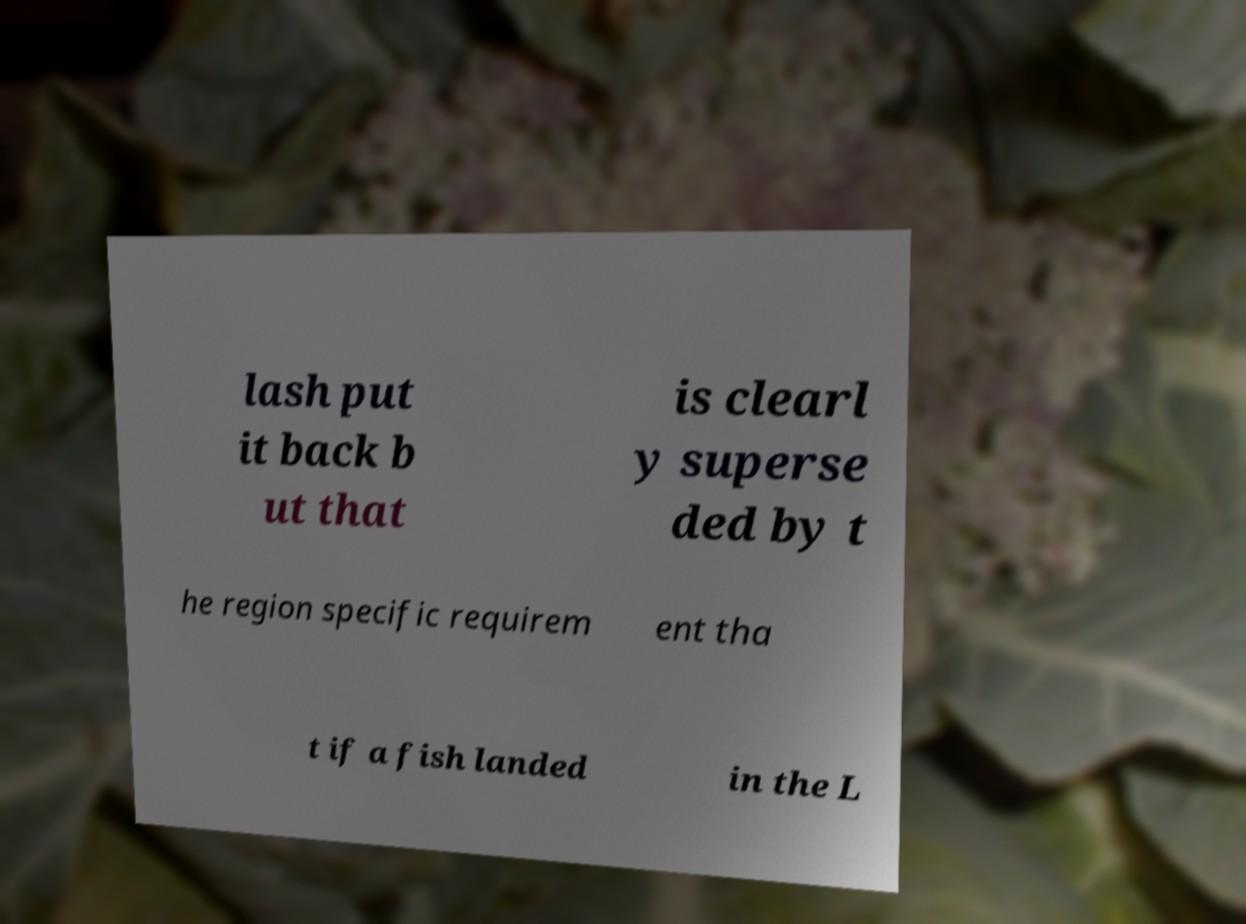What messages or text are displayed in this image? I need them in a readable, typed format. lash put it back b ut that is clearl y superse ded by t he region specific requirem ent tha t if a fish landed in the L 